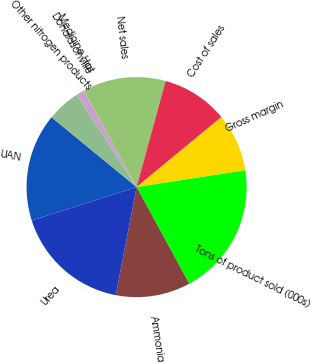Convert chart to OTSL. <chart><loc_0><loc_0><loc_500><loc_500><pie_chart><fcel>Net sales<fcel>Cost of sales<fcel>Gross margin<fcel>Tons of product sold (000s)<fcel>Ammonia<fcel>Urea<fcel>UAN<fcel>Other nitrogen products<fcel>Donaldsonville<fcel>Medicine Hat<nl><fcel>12.19%<fcel>9.76%<fcel>8.54%<fcel>19.5%<fcel>10.97%<fcel>17.06%<fcel>15.85%<fcel>4.88%<fcel>1.23%<fcel>0.01%<nl></chart> 